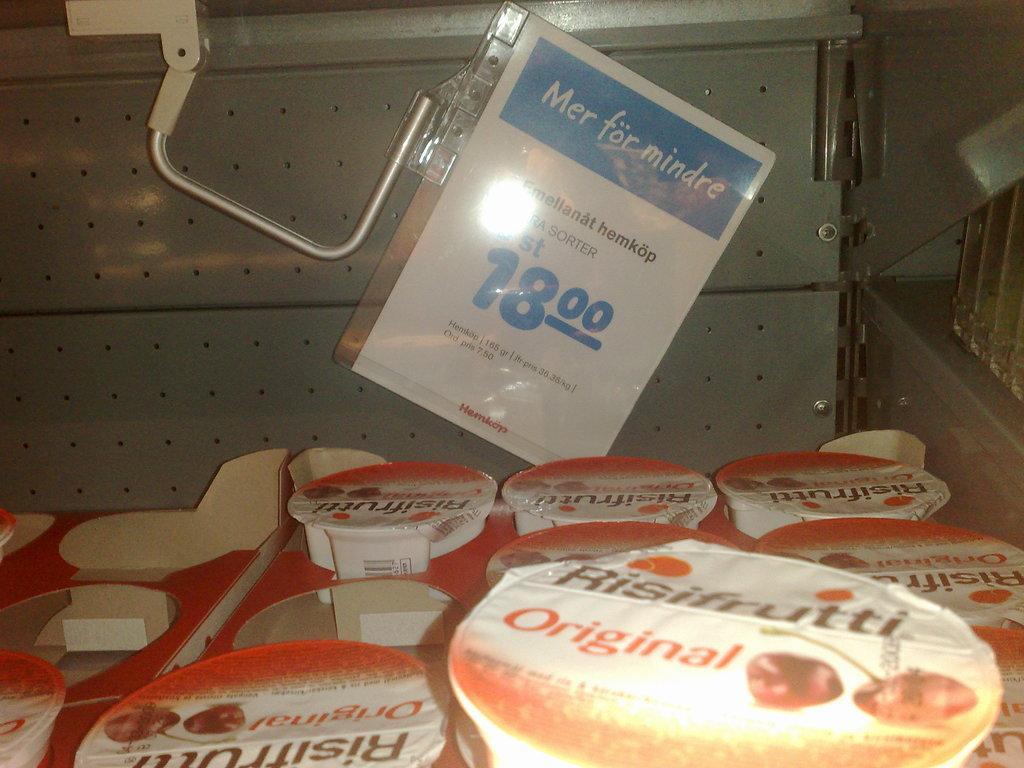Describe this image in one or two sentences. In this image we can see cups in the boxes. On the cups, we can see the labels with text and images. In the background, we can see a metal object. On the metal we can see a paper with text. 